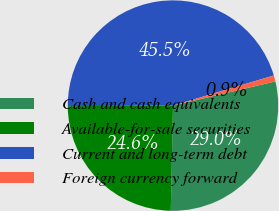Convert chart. <chart><loc_0><loc_0><loc_500><loc_500><pie_chart><fcel>Cash and cash equivalents<fcel>Available-for-sale securities<fcel>Current and long-term debt<fcel>Foreign currency forward<nl><fcel>29.03%<fcel>24.58%<fcel>45.46%<fcel>0.93%<nl></chart> 